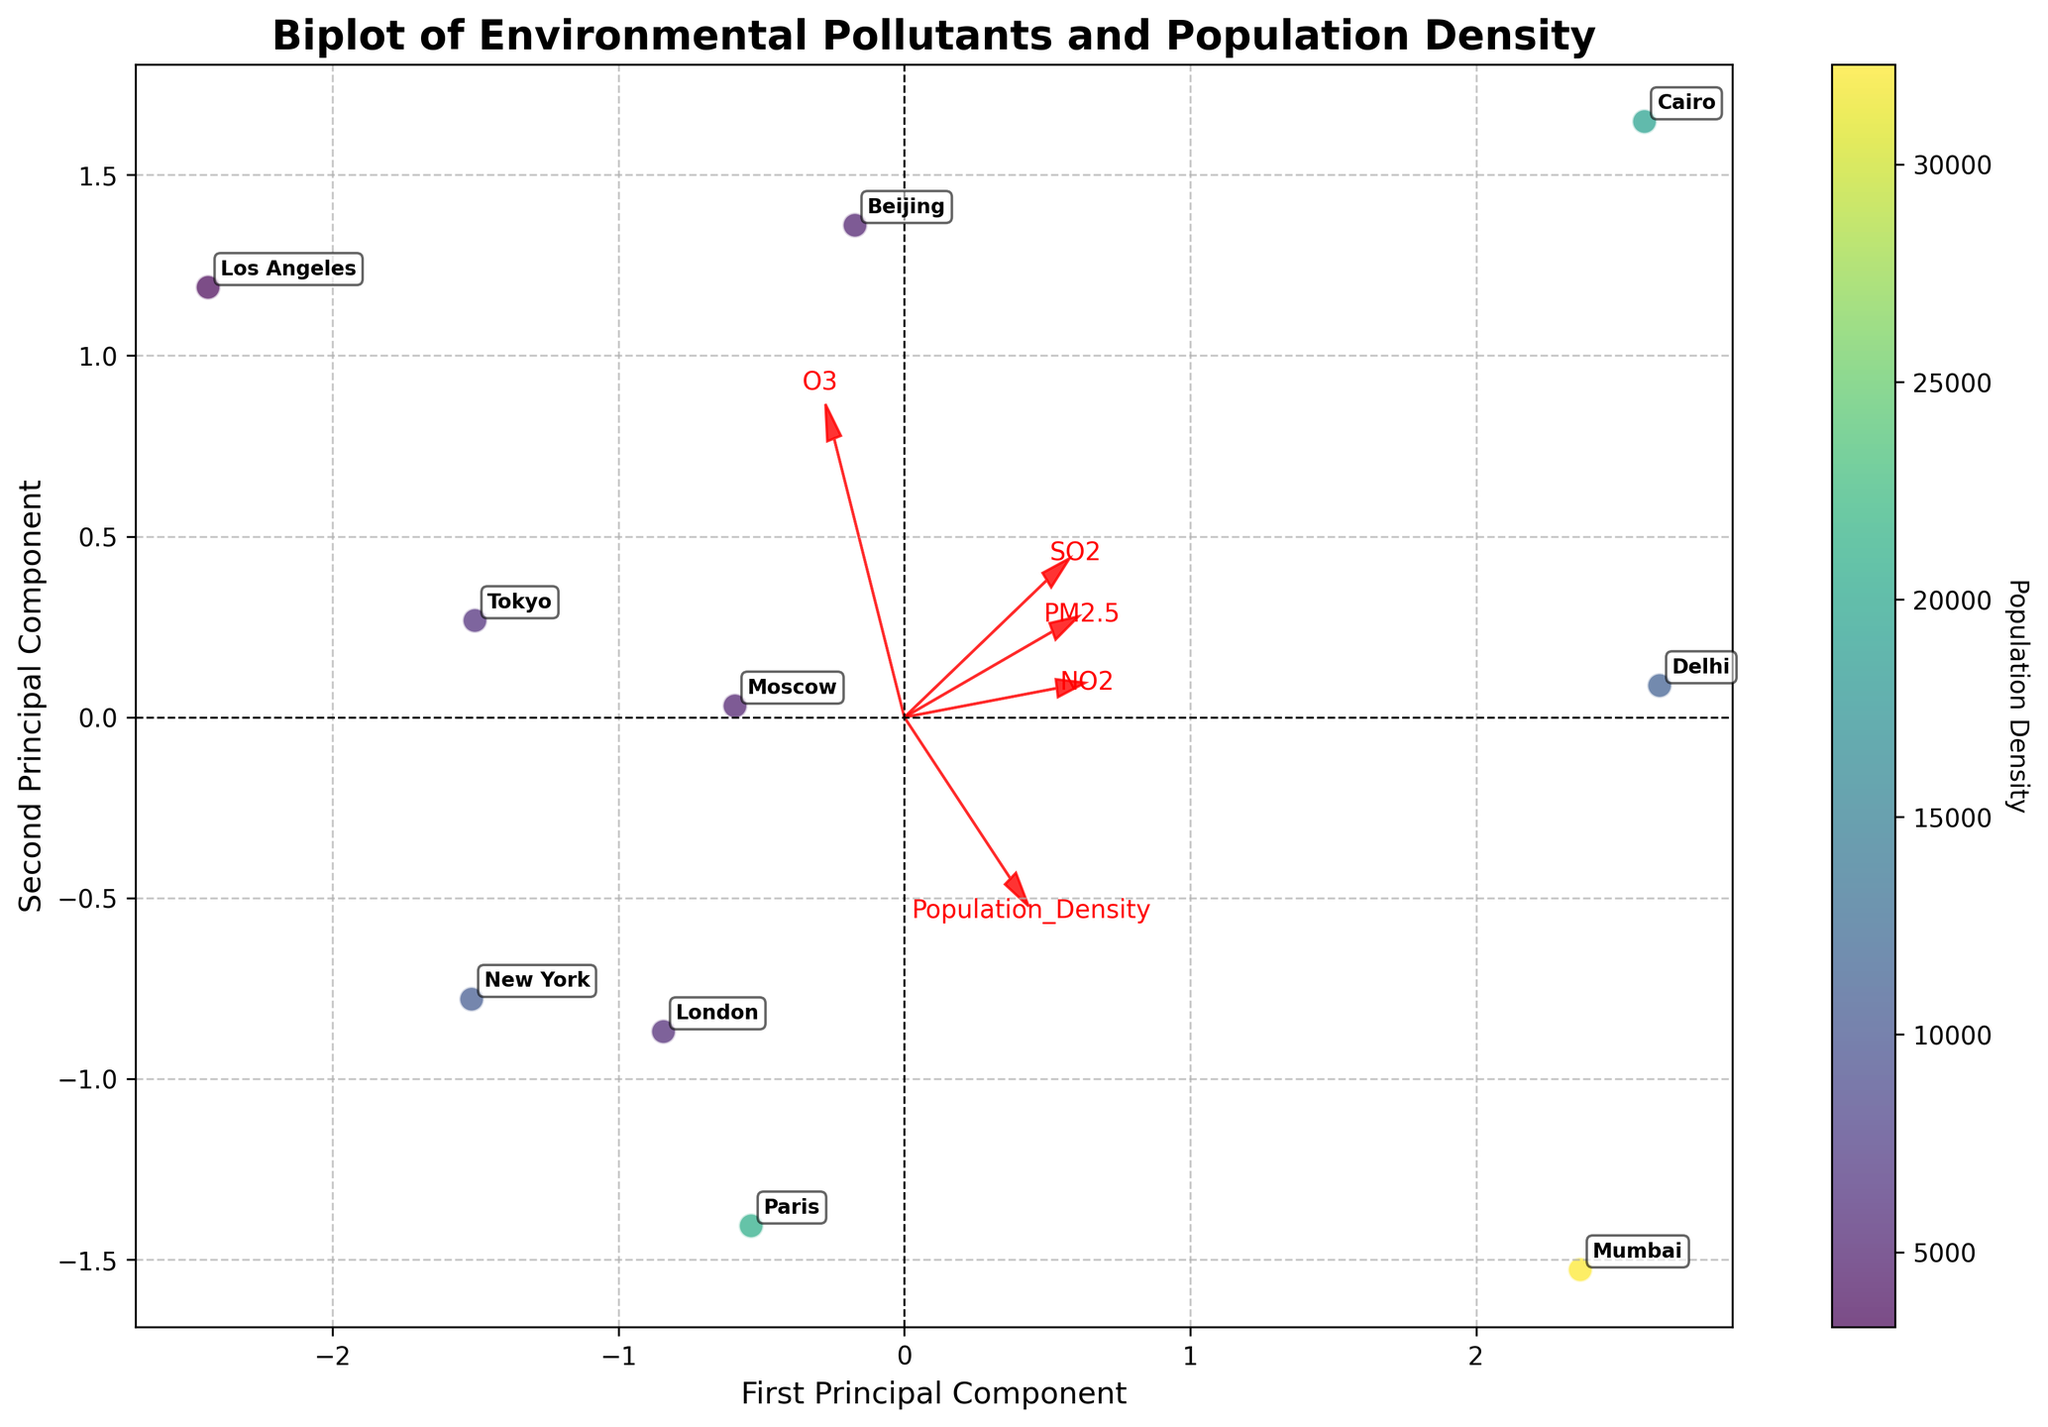How many cities are represented on the biplot? By counting the number of data points (scatter points) in the figure, we can determine the number of cities represented.
Answer: 10 Which city has the highest population density? The color intensity in the scatter plot corresponds to population density. The city with the darkest (most intense) color represents the highest population density. By looking at the color scale and the labeled scatter points, we find that Mumbai is the darkest.
Answer: Mumbai What does the arrow labeled 'PM2.5' indicate about its relationship with the first and second principal components? The direction and length of an arrow in a biplot represent the loadings and correlations with the principal components. The 'PM2.5' arrow points more towards the positive side of the first principal component and moderately towards the positive side of the second principal component, indicating that 'PM2.5' has a strong positive loading on the first principal component and a moderate positive loading on the second principal component.
Answer: Strong on first PC, moderate on second PC How does 'NO2' compare with 'SO2' in terms of their direction on the biplot? By looking at the direction of the arrows, we can observe that both 'NO2' and 'SO2' arrows point in roughly the same direction, though 'SO2' shows a slight negative loading on the second principal component, while 'NO2' shows a positive correlation with the second principal component.
Answer: Similar direction, but 'SO2' slightly different Which city appears to be an outlier based on the principal components? An outlier would be a city that lies far away from the cluster of other cities. In the biplot, Delhi is significantly separated from the others indicating it as an outlier.
Answer: Delhi What can you infer about the relationship between 'Population Density' and 'O3'? The direction of the 'Population Density' arrow compared to the 'O3' arrow helps determine their relationship. The arrows for 'Population Density' and 'O3' have a small angle between them, indicating a weak but positive correlation.
Answer: Weak positive correlation Which environmental pollutant has the strongest loading on the second principal component? By examining the length of the arrows and their vector components along the second principal component axis, 'NO2' has the strongest loading on the second principal component.
Answer: 'NO2' How does Los Angeles compare to Beijing in terms of pollution levels and population density? Both cities' positions in the biplot can be compared by looking at their coordinates and labels. Los Angeles is positioned with low pollution levels and population density, while Beijing shows higher pollution levels and population density. This is consistent with Los Angeles being close to the origin and Beijing farther along the positive side of the first principal component.
Answer: Los Angeles lower, Beijing higher Is there a noticeable trend between urban population density and 'PM2.5' levels among the cities? By considering the general direction and the grouping of cities in the biplot along with the arrows for 'Population Density' and 'PM2.5', it appears that cities with higher population density also show higher 'PM2.5' levels, as the arrows for these variables are relatively aligned.
Answer: Yes Which principal component explains the majority of the variance? The principal component explaining the majority of the variance is indicated by the axis on which the data points are more spread out. The longer axis for the scatterplot represents a higher explained variance. The plot indicates the first principal component explains most of the variance.
Answer: First principal component 